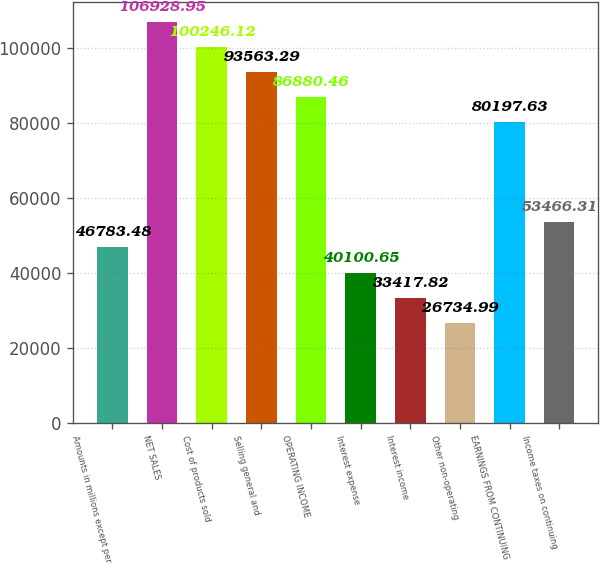<chart> <loc_0><loc_0><loc_500><loc_500><bar_chart><fcel>Amounts in millions except per<fcel>NET SALES<fcel>Cost of products sold<fcel>Selling general and<fcel>OPERATING INCOME<fcel>Interest expense<fcel>Interest income<fcel>Other non-operating<fcel>EARNINGS FROM CONTINUING<fcel>Income taxes on continuing<nl><fcel>46783.5<fcel>106929<fcel>100246<fcel>93563.3<fcel>86880.5<fcel>40100.7<fcel>33417.8<fcel>26735<fcel>80197.6<fcel>53466.3<nl></chart> 